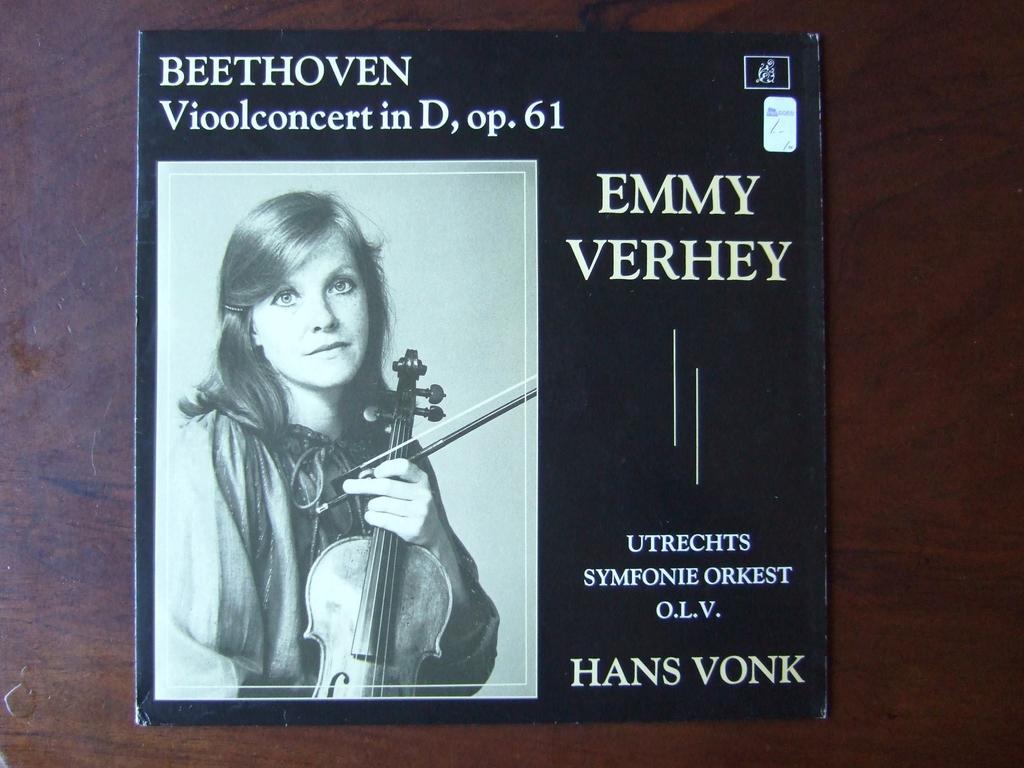Describe this image in one or two sentences. The picture consists of a book placed on a table. On the cover of the book we can see text and a woman holding violin. 